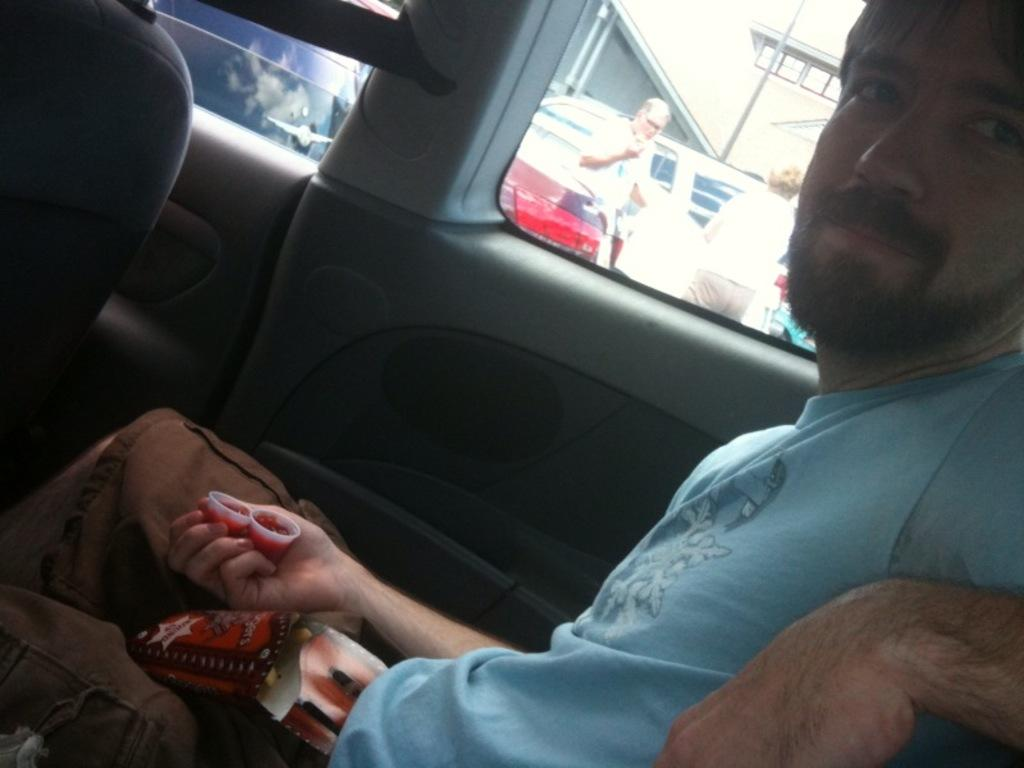What is the man in the image doing? The man is sitting in a car. What is the man wearing in the image? The man is wearing a blue t-shirt. What can be seen in the background of the image? There are other vehicles and people standing on the ground in the background of the image. How many sheep are visible in the image? There are no sheep present in the image. What type of shelf can be seen in the background of the image? There is no shelf present in the image. 